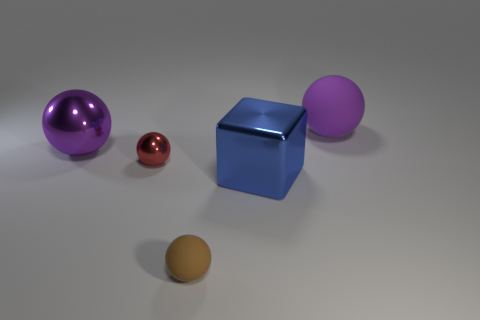Add 2 blue blocks. How many objects exist? 7 Subtract all cubes. How many objects are left? 4 Subtract 1 brown spheres. How many objects are left? 4 Subtract all big purple shiny things. Subtract all blue metallic blocks. How many objects are left? 3 Add 3 red metal balls. How many red metal balls are left? 4 Add 2 spheres. How many spheres exist? 6 